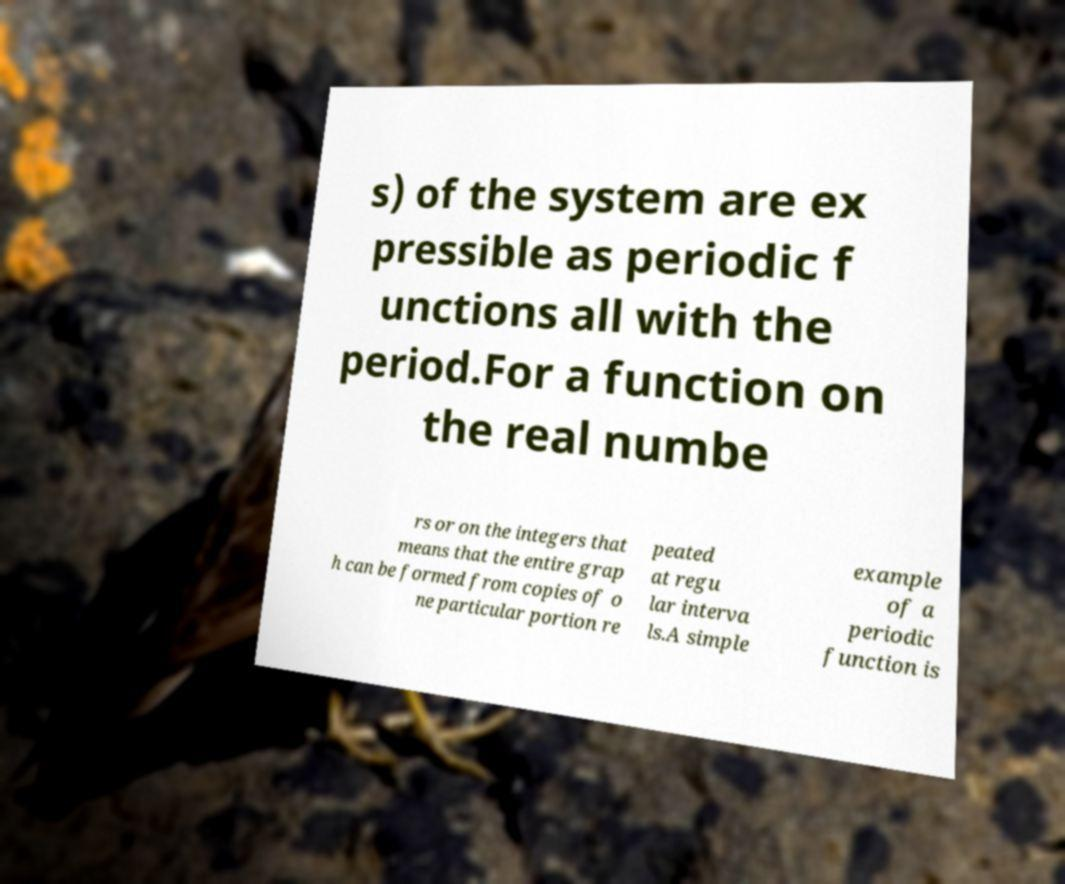Please read and relay the text visible in this image. What does it say? s) of the system are ex pressible as periodic f unctions all with the period.For a function on the real numbe rs or on the integers that means that the entire grap h can be formed from copies of o ne particular portion re peated at regu lar interva ls.A simple example of a periodic function is 